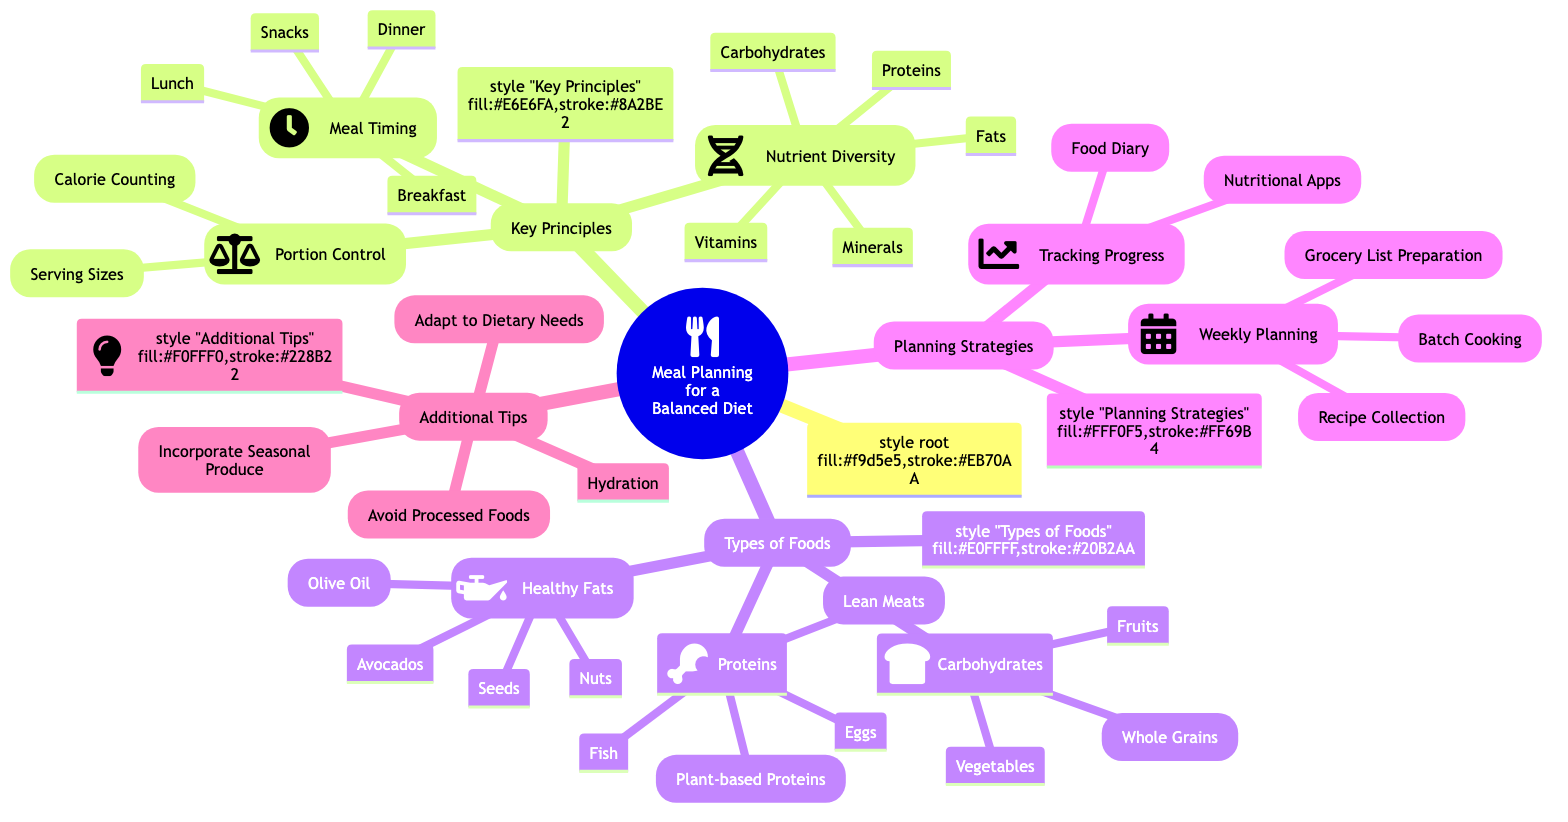What are the three key principles of meal planning? The diagram lists "Key Principles." Below this node, there are three sub-nodes directly mentioned: "Nutrient Diversity," "Portion Control," and "Meal Timing." These represent the essential principles for meal planning.
Answer: Nutrient Diversity, Portion Control, Meal Timing How many types of foods are specified in the diagram? The diagram has a node titled "Types of Foods," which branches into three categories: "Proteins," "Carbohydrates," and "Healthy Fats." This indicates there are three distinct types of foods mentioned in the diagram.
Answer: 3 What types of proteins are listed under meal planning? Under the "Proteins" node, there are four sub-nodes specifically detailing the types of proteins: "Lean Meats," "Fish," "Eggs," and "Plant-based Proteins." This provides direct information about the protein types included in the meal plan.
Answer: Lean Meats, Fish, Eggs, Plant-based Proteins Which planning strategy focuses on recipe collection? Within the "Planning Strategies" section, there is a sub-node called "Weekly Planning." Under this sub-node, one of the components mentioned is "Recipe Collection." This indicates the relationship between the planning strategy and the specific focus on recipes.
Answer: Weekly Planning How many additional tips are provided in the diagram? In the "Additional Tips" section, there are four separate items listed: "Hydration," "Avoid Processed Foods," "Incorporate Seasonal Produce," and "Adapt to Dietary Needs." By counting these items, one can arrive at the total number of tips.
Answer: 4 What types of carbohydrates are included in the meal planning? The "Carbohydrates" node consists of three sub-nodes that explicitly detail the types of carbohydrates: "Whole Grains," "Fruits," and "Vegetables." Thus, these can be directly identified as the specified carbohydrate types.
Answer: Whole Grains, Fruits, Vegetables What is the focus of the "Tracking Progress" strategy? Under the "Planning Strategies" node, there is a specific sub-node titled "Tracking Progress," which contains two items: "Food Diary" and "Nutritional Apps." This indicates the focus on how one can track their dietary progress.
Answer: Food Diary, Nutritional Apps Which healthy fat source is listed first in the diagram? The node labeled "Healthy Fats" contains four sub-nodes: "Olive Oil," "Nuts," "Avocados," and "Seeds." The first one listed is "Olive Oil," indicating it is the primary source mentioned in the diagram.
Answer: Olive Oil 